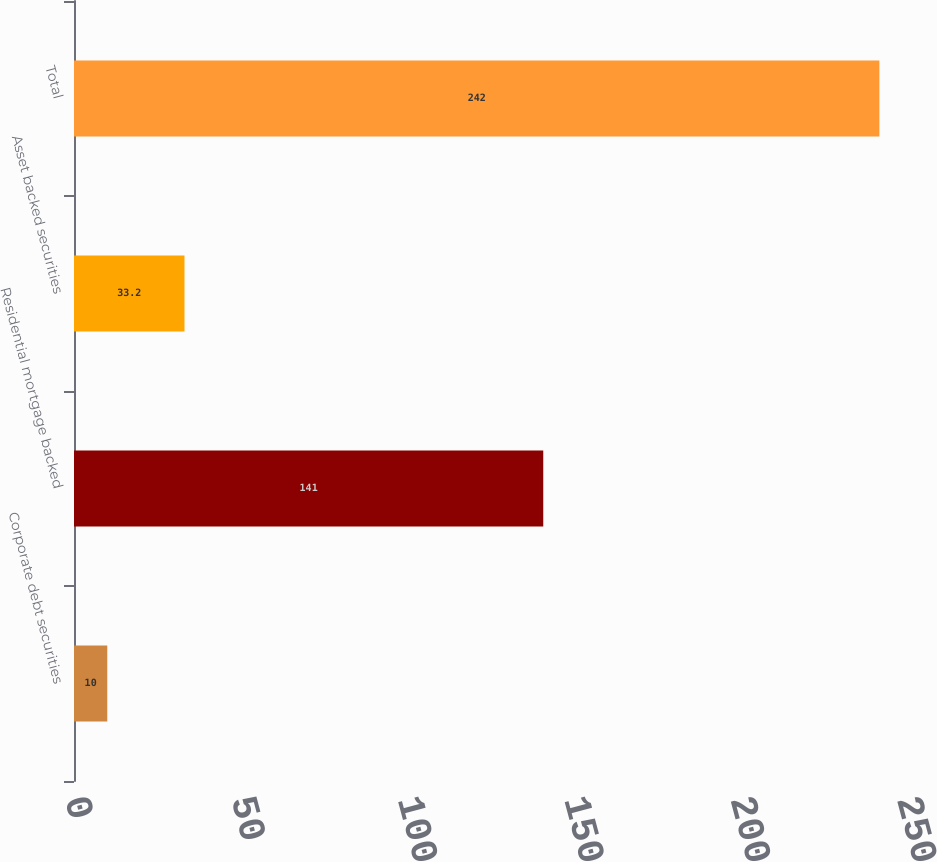Convert chart. <chart><loc_0><loc_0><loc_500><loc_500><bar_chart><fcel>Corporate debt securities<fcel>Residential mortgage backed<fcel>Asset backed securities<fcel>Total<nl><fcel>10<fcel>141<fcel>33.2<fcel>242<nl></chart> 